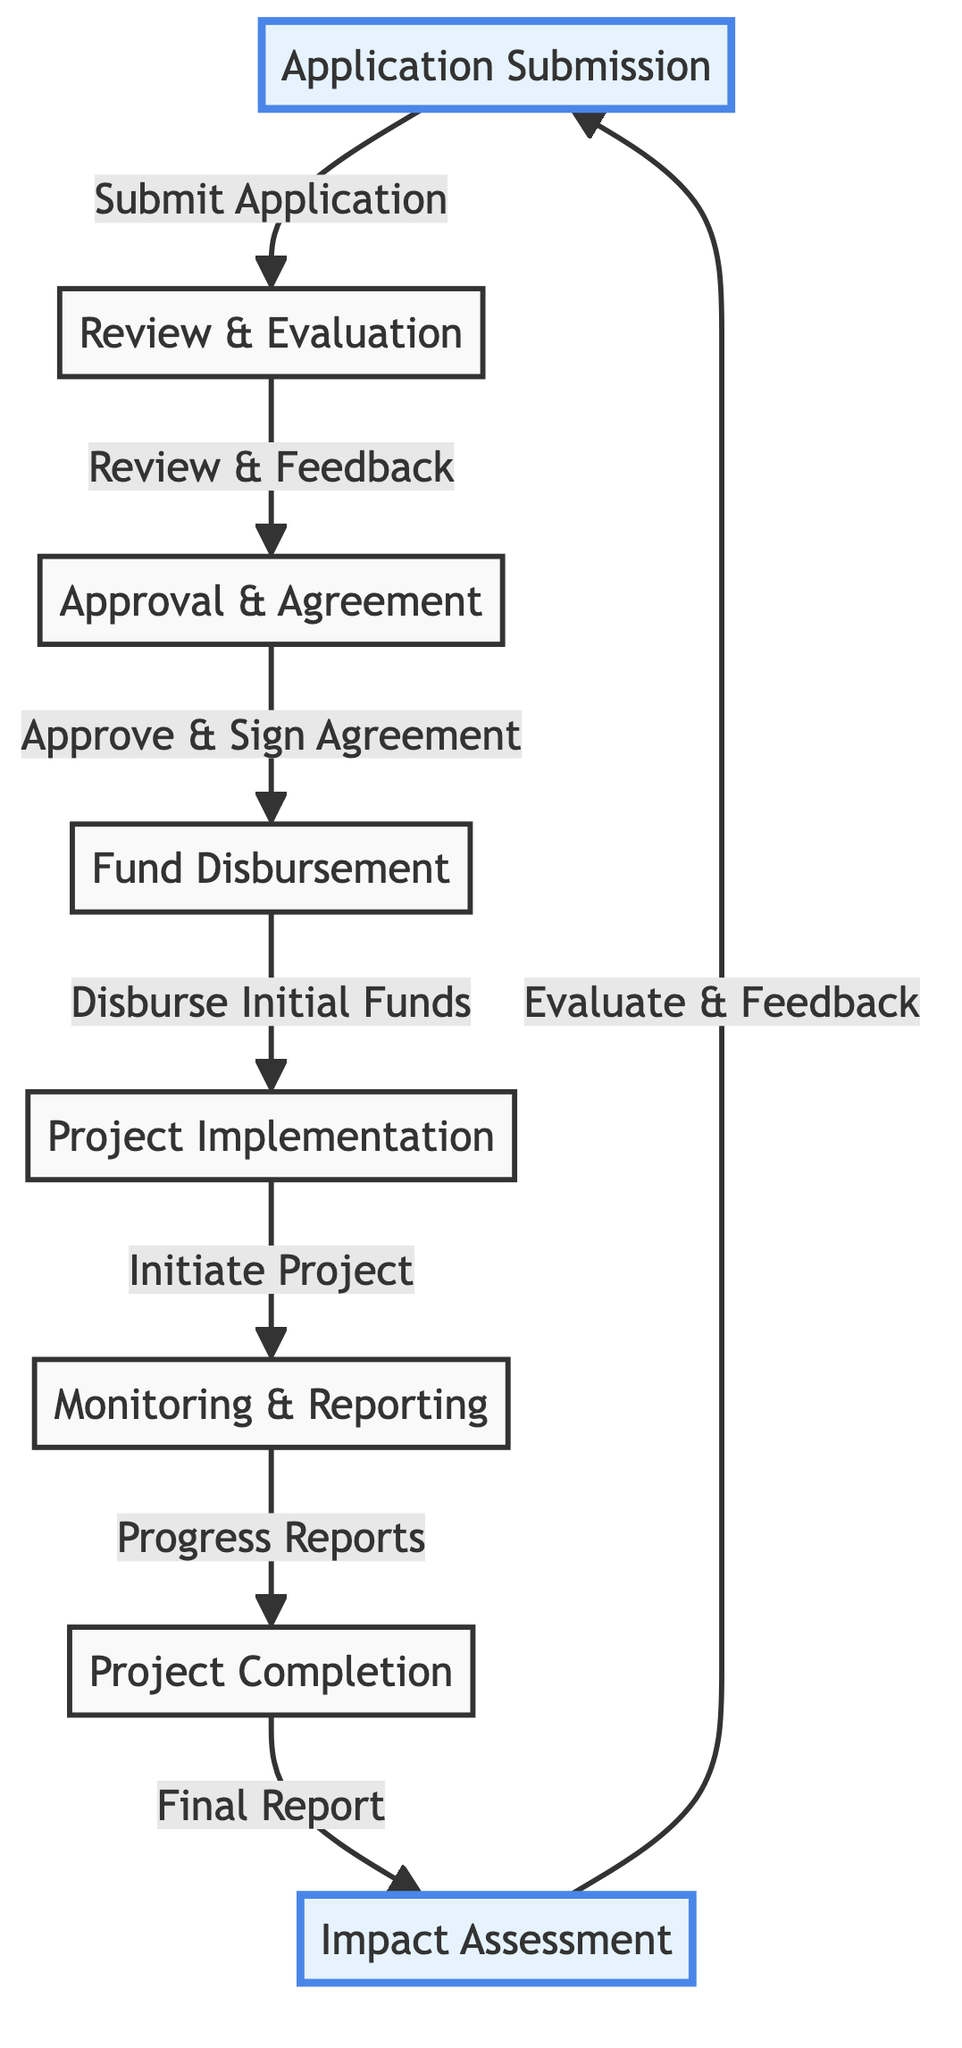What is the first stage in the lifecycle? The first stage in the lifecycle is "Application Submission." This can be found as the starting point of the flowchart before any arrows leading to subsequent stages.
Answer: Application Submission How many stages are there in total? Counting all the labeled nodes in the diagram, there are eight distinct stages. The stages are "Application Submission," "Review & Evaluation," "Approval & Agreement," "Fund Disbursement," "Project Implementation," "Monitoring & Reporting," "Project Completion," and "Impact Assessment."
Answer: 8 What comes after the "Monitoring & Reporting" stage? After "Monitoring & Reporting," the next stage indicated by an arrow leading away is "Project Completion." This flows directly from monitoring to completion in the diagram.
Answer: Project Completion What is the final stage of the lifecycle? The final stage is labeled "Impact Assessment." This is the last node in the sequence, following "Project Completion," and it loops back to the "Application Submission" stage in the diagram.
Answer: Impact Assessment What action follows "Approval & Agreement"? The action that follows "Approval & Agreement" is "Fund Disbursement." This can be seen as the next step that is connected by an arrow originating from the approval stage.
Answer: Fund Disbursement What stage requires "Progress Reports"? The stage that requires "Progress Reports" is "Monitoring & Reporting." This is clearly indicated in the flowchart where the arrow from "Implementation" points to "Monitoring" and mentions the need for progress updates.
Answer: Monitoring & Reporting Which stages are highlighted in the diagram? The highlighted stages in the diagram are "Application Submission" and "Impact Assessment." This distinction is noted with a different background color and stroke style for emphasis.
Answer: Application Submission and Impact Assessment What is initiated during the "Fund Disbursement" stage? During the "Fund Disbursement" stage, the action initiated is "Disburse Initial Funds." This can be deduced from the action label that connects this stage to the following implementation stage.
Answer: Disburse Initial Funds 